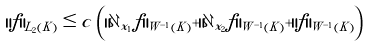Convert formula to latex. <formula><loc_0><loc_0><loc_500><loc_500>\| f \| _ { L _ { 2 } ( K ) } \leq c \, \left ( \| \partial _ { x _ { 1 } } f \| _ { W ^ { - 1 } ( K ) } + \| \partial _ { x _ { 2 } } f \| _ { W ^ { - 1 } ( K ) } + \| f \| _ { W ^ { - 1 } ( K ) } \right )</formula> 